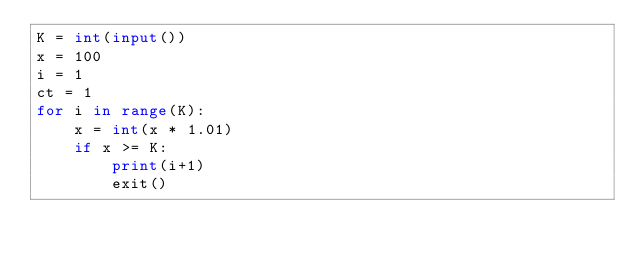<code> <loc_0><loc_0><loc_500><loc_500><_Python_>K = int(input())
x = 100
i = 1
ct = 1
for i in range(K):
    x = int(x * 1.01)
    if x >= K:
        print(i+1)
        exit()
</code> 